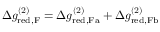<formula> <loc_0><loc_0><loc_500><loc_500>\begin{array} { r } { \Delta g _ { r e d , F } ^ { ( 2 ) } = \Delta g _ { r e d , F a } ^ { ( 2 ) } + \Delta g _ { r e d , F b } ^ { ( 2 ) } } \end{array}</formula> 